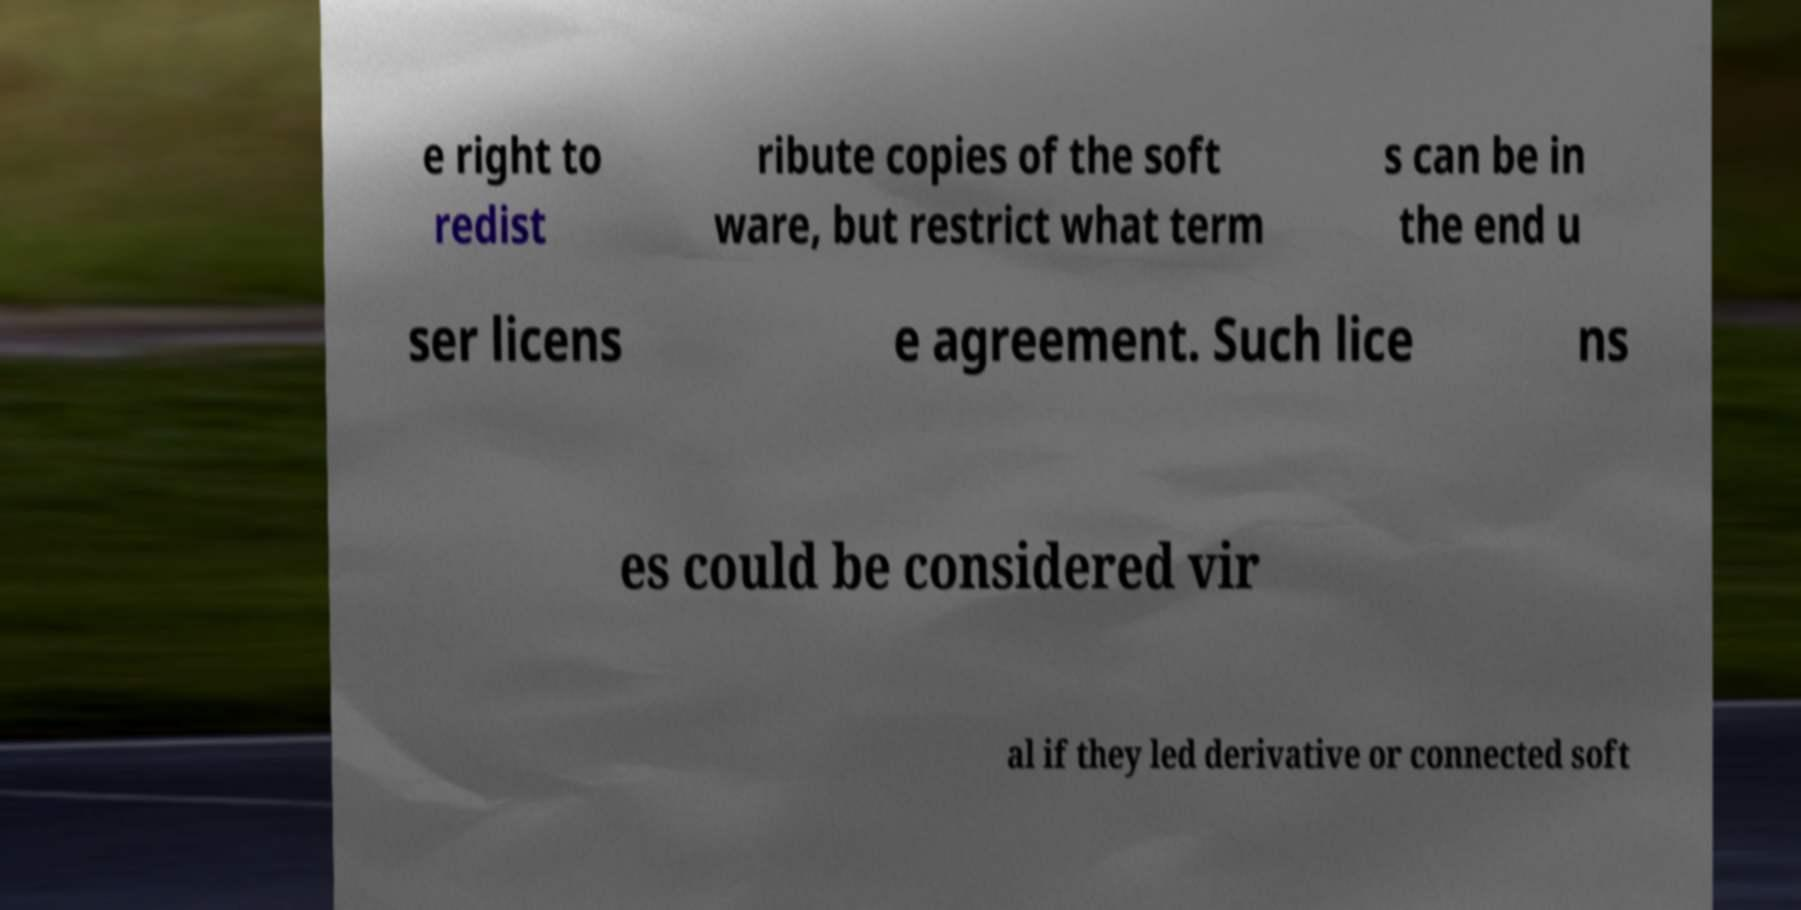I need the written content from this picture converted into text. Can you do that? e right to redist ribute copies of the soft ware, but restrict what term s can be in the end u ser licens e agreement. Such lice ns es could be considered vir al if they led derivative or connected soft 